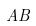<formula> <loc_0><loc_0><loc_500><loc_500>A B</formula> 